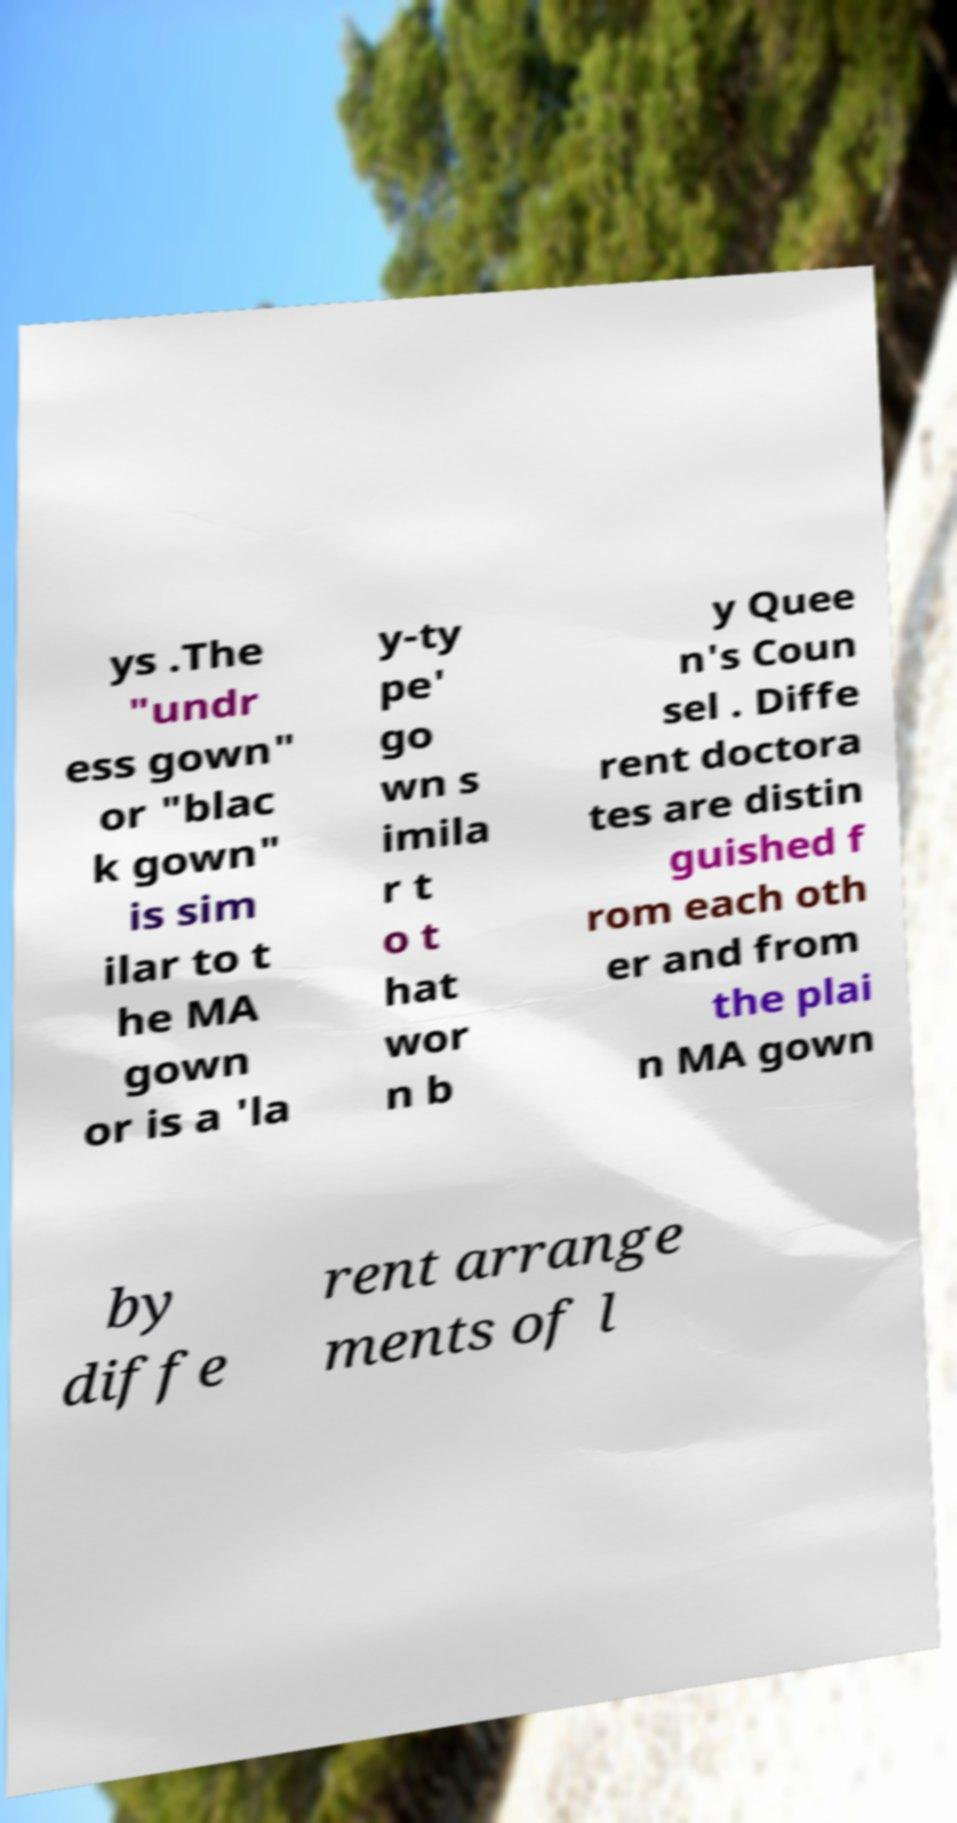What messages or text are displayed in this image? I need them in a readable, typed format. ys .The "undr ess gown" or "blac k gown" is sim ilar to t he MA gown or is a 'la y-ty pe' go wn s imila r t o t hat wor n b y Quee n's Coun sel . Diffe rent doctora tes are distin guished f rom each oth er and from the plai n MA gown by diffe rent arrange ments of l 